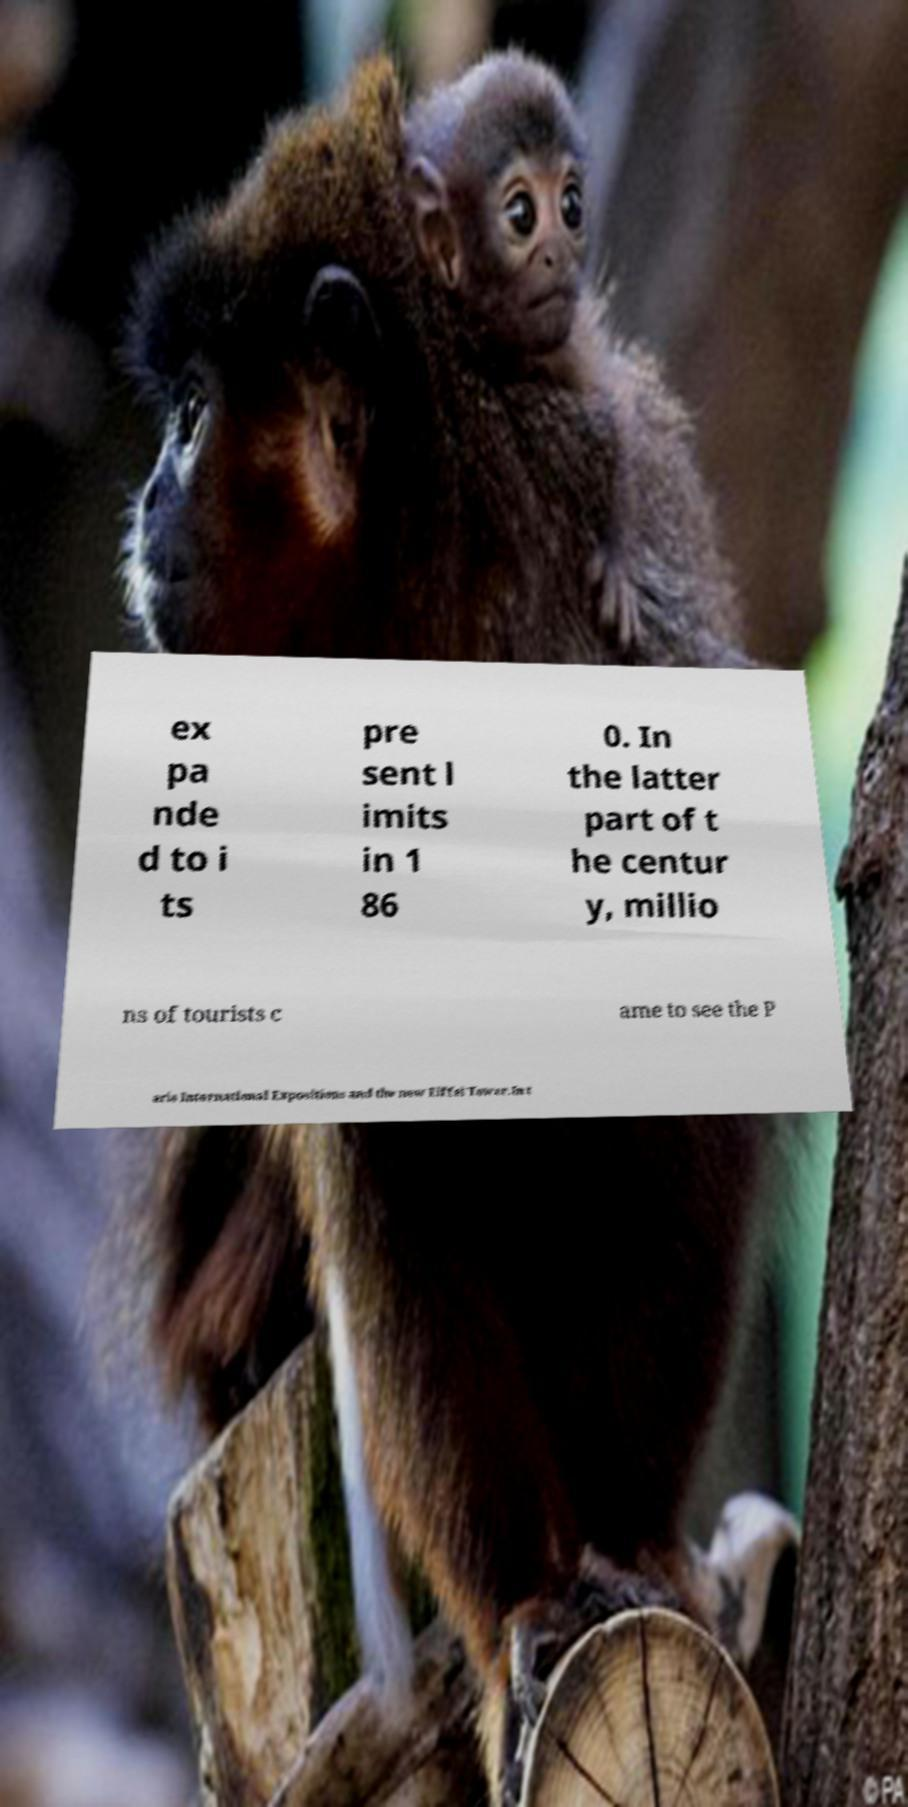Please read and relay the text visible in this image. What does it say? ex pa nde d to i ts pre sent l imits in 1 86 0. In the latter part of t he centur y, millio ns of tourists c ame to see the P aris International Expositions and the new Eiffel Tower.In t 